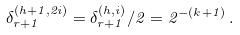<formula> <loc_0><loc_0><loc_500><loc_500>\delta _ { r + 1 } ^ { ( h + 1 , 2 i ) } = \delta _ { r + 1 } ^ { ( h , i ) } / 2 = 2 ^ { - ( k + 1 ) } \, .</formula> 